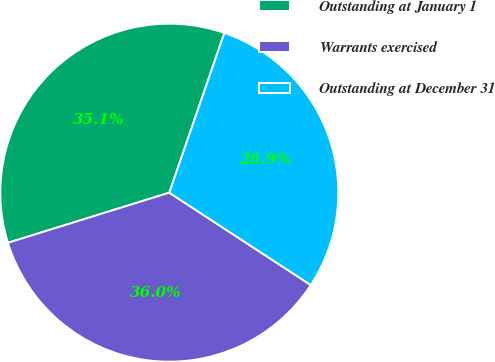Convert chart to OTSL. <chart><loc_0><loc_0><loc_500><loc_500><pie_chart><fcel>Outstanding at January 1<fcel>Warrants exercised<fcel>Outstanding at December 31<nl><fcel>35.08%<fcel>36.0%<fcel>28.92%<nl></chart> 